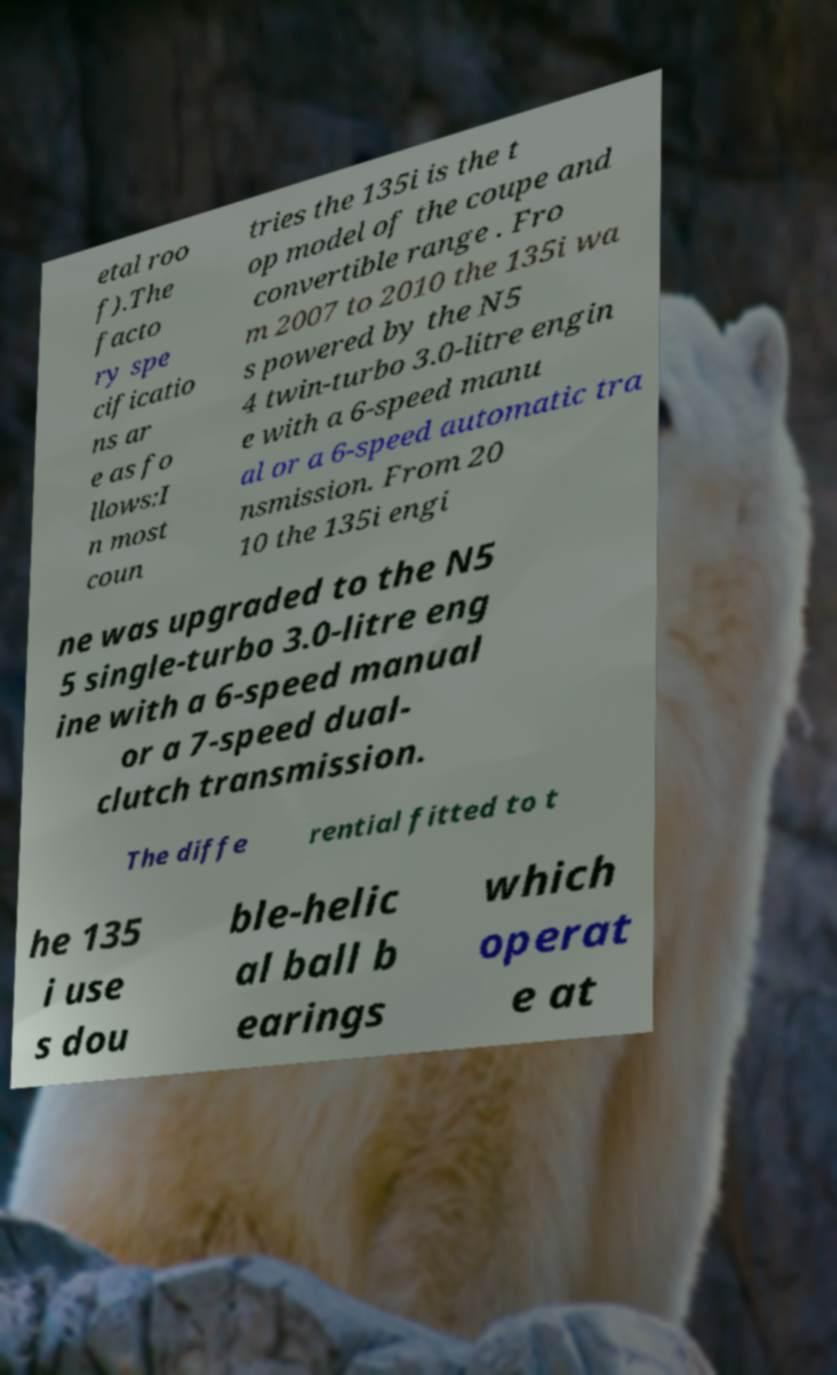There's text embedded in this image that I need extracted. Can you transcribe it verbatim? etal roo f).The facto ry spe cificatio ns ar e as fo llows:I n most coun tries the 135i is the t op model of the coupe and convertible range . Fro m 2007 to 2010 the 135i wa s powered by the N5 4 twin-turbo 3.0-litre engin e with a 6-speed manu al or a 6-speed automatic tra nsmission. From 20 10 the 135i engi ne was upgraded to the N5 5 single-turbo 3.0-litre eng ine with a 6-speed manual or a 7-speed dual- clutch transmission. The diffe rential fitted to t he 135 i use s dou ble-helic al ball b earings which operat e at 